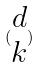Convert formula to latex. <formula><loc_0><loc_0><loc_500><loc_500>( \begin{matrix} d \\ k \end{matrix} )</formula> 